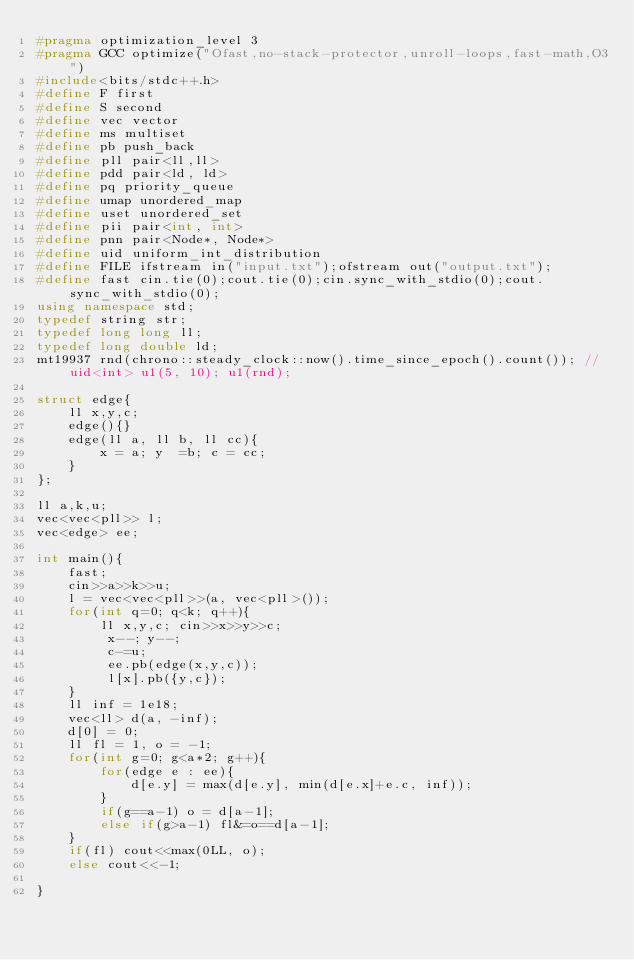<code> <loc_0><loc_0><loc_500><loc_500><_C++_>#pragma optimization_level 3
#pragma GCC optimize("Ofast,no-stack-protector,unroll-loops,fast-math,O3")
#include<bits/stdc++.h>
#define F first
#define S second
#define vec vector
#define ms multiset
#define pb push_back
#define pll pair<ll,ll>
#define pdd pair<ld, ld>
#define pq priority_queue
#define umap unordered_map
#define uset unordered_set
#define pii pair<int, int>
#define pnn pair<Node*, Node*>
#define uid uniform_int_distribution
#define FILE ifstream in("input.txt");ofstream out("output.txt");
#define fast cin.tie(0);cout.tie(0);cin.sync_with_stdio(0);cout.sync_with_stdio(0);
using namespace std;
typedef string str;
typedef long long ll;
typedef long double ld;
mt19937 rnd(chrono::steady_clock::now().time_since_epoch().count()); //uid<int> u1(5, 10); u1(rnd);

struct edge{
    ll x,y,c;
    edge(){}
    edge(ll a, ll b, ll cc){
        x = a; y  =b; c = cc;
    }
};

ll a,k,u;
vec<vec<pll>> l;
vec<edge> ee;

int main(){
    fast;
    cin>>a>>k>>u;
    l = vec<vec<pll>>(a, vec<pll>());
    for(int q=0; q<k; q++){
        ll x,y,c; cin>>x>>y>>c;
         x--; y--;
         c-=u;
         ee.pb(edge(x,y,c));
         l[x].pb({y,c});
    }
    ll inf = 1e18;
    vec<ll> d(a, -inf);
    d[0] = 0;
    ll fl = 1, o = -1;
    for(int g=0; g<a*2; g++){
        for(edge e : ee){
            d[e.y] = max(d[e.y], min(d[e.x]+e.c, inf));
        }
        if(g==a-1) o = d[a-1];
        else if(g>a-1) fl&=o==d[a-1];
    }
    if(fl) cout<<max(0LL, o);
    else cout<<-1;

}</code> 